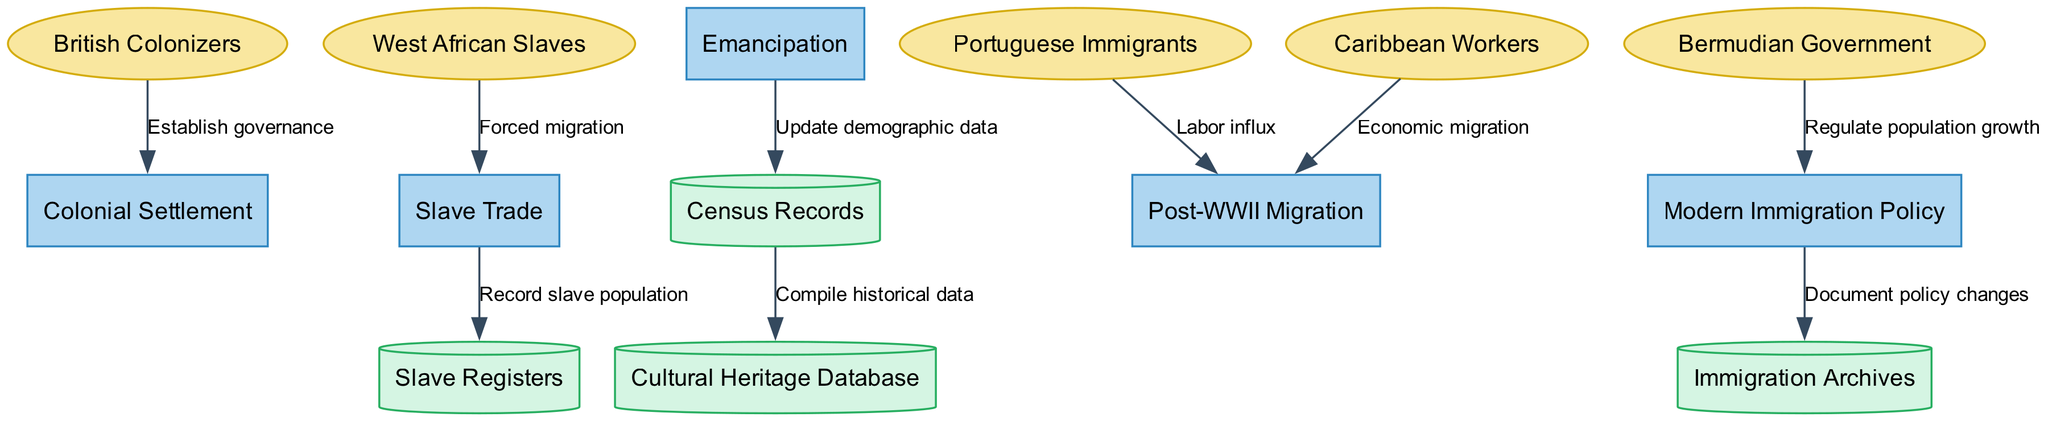What are the processes depicted in the diagram? The diagram includes five processes: Colonial Settlement, Slave Trade, Emancipation, Post-WWII Migration, and Modern Immigration Policy. These processes represent significant periods or events in Bermuda's immigration and demographic history.
Answer: Colonial Settlement, Slave Trade, Emancipation, Post-WWII Migration, Modern Immigration Policy How many external entities are there in the diagram? The diagram lists five external entities: British Colonizers, West African Slaves, Portuguese Immigrants, Caribbean Workers, and Bermudian Government. Each entity represents a group that interacted with the immigration processes over time.
Answer: 5 What is the flow label from Modern Immigration Policy to Immigration Archives? The flow label indicates that there is a documentation of policy changes from Modern Immigration Policy to Immigration Archives. This illustrates the relationship between current policies and historical documentation.
Answer: Document policy changes Which process is directly connected to Slave Registers? The Slave Trade process is directly connected to Slave Registers, indicating that records of the slave population were generated as a result of the slave trade activities.
Answer: Slave Trade What is the relationship between the Emancipation process and Census Records? Emancipation updates the demographic data in the Census Records, suggesting that the end of slavery had a significant impact on the population statistics recorded.
Answer: Update demographic data What external entity leads to the Colonial Settlement process? The British Colonizers are the external entity that establishes governance, leading directly to the Colonial Settlement process in Bermuda's history.
Answer: British Colonizers Which two processes receive data flows from Post-WWII Migration? The Post-WWII Migration process sends flows to both the Immigration Archives and contributes to demographic data, but explicitly receives data from Portuguese Immigrants and Caribbean Workers as labor influx and economic migration.
Answer: Immigration Archives and Census Records Which data store is connected to the Cultural Heritage Database? The Census Records store is connected to the Cultural Heritage Database, indicating that historical demographic data compilation contributes to understanding Bermuda's cultural heritage.
Answer: Census Records How does the Bermudian Government influence Modern Immigration Policy? The Bermudian Government regulates population growth, which directly influences the creation and adaptation of Modern Immigration Policy in the context of demographic changes.
Answer: Regulate population growth 